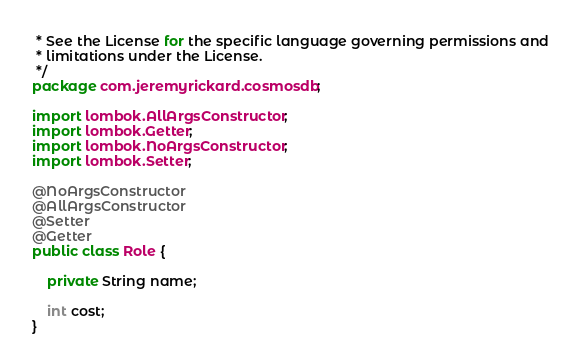Convert code to text. <code><loc_0><loc_0><loc_500><loc_500><_Java_> * See the License for the specific language governing permissions and
 * limitations under the License.
 */
package com.jeremyrickard.cosmosdb;

import lombok.AllArgsConstructor;
import lombok.Getter;
import lombok.NoArgsConstructor;
import lombok.Setter;

@NoArgsConstructor
@AllArgsConstructor
@Setter
@Getter
public class Role {

    private String name;

    int cost;
}
</code> 